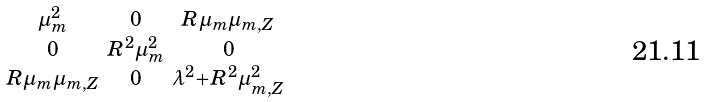<formula> <loc_0><loc_0><loc_500><loc_500>\begin{smallmatrix} \mu _ { m } ^ { 2 } & 0 & R \mu _ { m } \mu _ { m , Z } \\ 0 & R ^ { 2 } \mu ^ { 2 } _ { m } & 0 \\ R \mu _ { m } \mu _ { m , Z } & 0 & \lambda ^ { 2 } + R ^ { 2 } \mu ^ { 2 } _ { m , Z } \end{smallmatrix}</formula> 